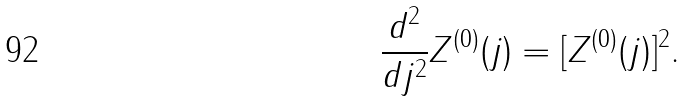Convert formula to latex. <formula><loc_0><loc_0><loc_500><loc_500>\frac { d ^ { 2 } } { d j ^ { 2 } } Z ^ { ( 0 ) } ( j ) = [ Z ^ { ( 0 ) } ( j ) ] ^ { 2 } .</formula> 